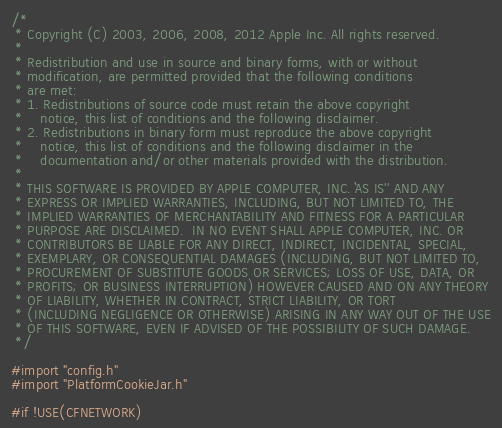Convert code to text. <code><loc_0><loc_0><loc_500><loc_500><_ObjectiveC_>/*
 * Copyright (C) 2003, 2006, 2008, 2012 Apple Inc. All rights reserved.
 *
 * Redistribution and use in source and binary forms, with or without
 * modification, are permitted provided that the following conditions
 * are met:
 * 1. Redistributions of source code must retain the above copyright
 *    notice, this list of conditions and the following disclaimer.
 * 2. Redistributions in binary form must reproduce the above copyright
 *    notice, this list of conditions and the following disclaimer in the
 *    documentation and/or other materials provided with the distribution.
 *
 * THIS SOFTWARE IS PROVIDED BY APPLE COMPUTER, INC. ``AS IS'' AND ANY
 * EXPRESS OR IMPLIED WARRANTIES, INCLUDING, BUT NOT LIMITED TO, THE
 * IMPLIED WARRANTIES OF MERCHANTABILITY AND FITNESS FOR A PARTICULAR
 * PURPOSE ARE DISCLAIMED.  IN NO EVENT SHALL APPLE COMPUTER, INC. OR
 * CONTRIBUTORS BE LIABLE FOR ANY DIRECT, INDIRECT, INCIDENTAL, SPECIAL,
 * EXEMPLARY, OR CONSEQUENTIAL DAMAGES (INCLUDING, BUT NOT LIMITED TO,
 * PROCUREMENT OF SUBSTITUTE GOODS OR SERVICES; LOSS OF USE, DATA, OR
 * PROFITS; OR BUSINESS INTERRUPTION) HOWEVER CAUSED AND ON ANY THEORY
 * OF LIABILITY, WHETHER IN CONTRACT, STRICT LIABILITY, OR TORT
 * (INCLUDING NEGLIGENCE OR OTHERWISE) ARISING IN ANY WAY OUT OF THE USE
 * OF THIS SOFTWARE, EVEN IF ADVISED OF THE POSSIBILITY OF SUCH DAMAGE.
 */

#import "config.h"
#import "PlatformCookieJar.h"

#if !USE(CFNETWORK)
</code> 